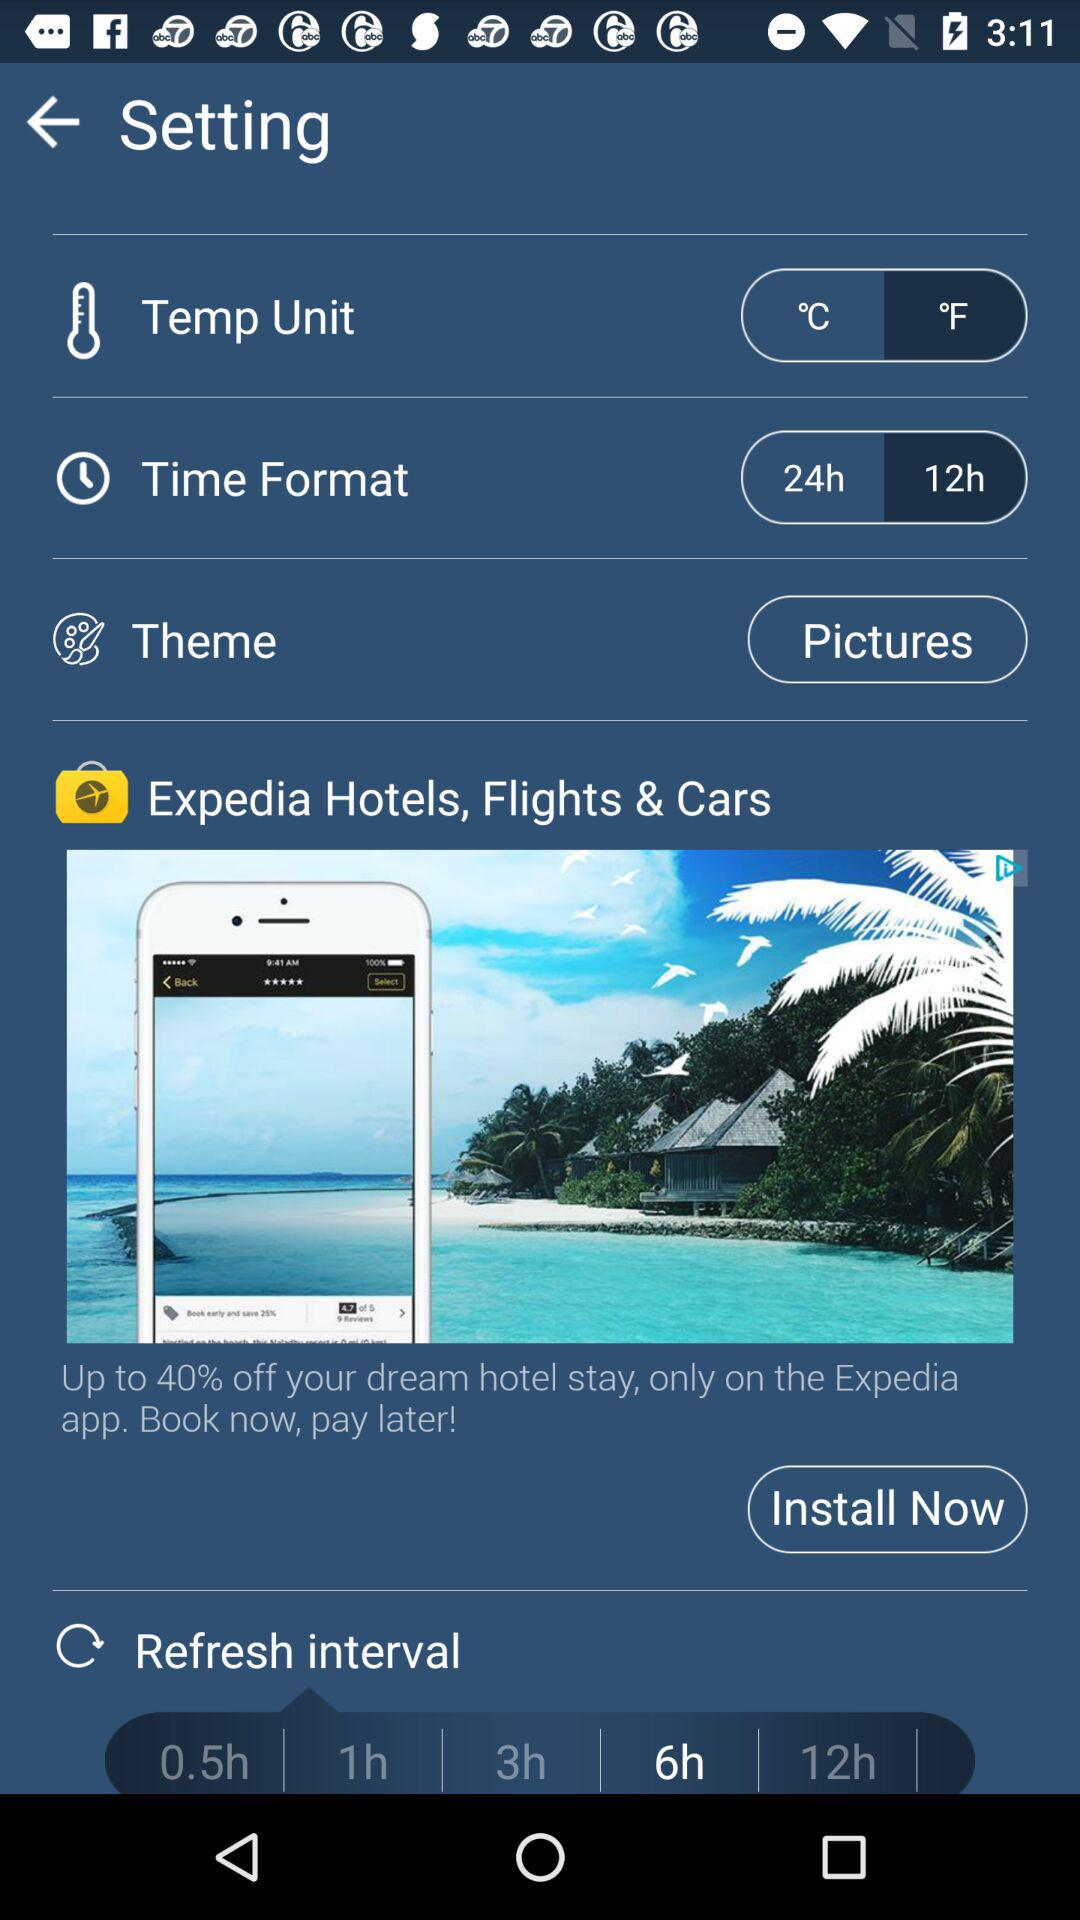Which theme is selected? The selected theme is "Pictures". 